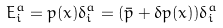<formula> <loc_0><loc_0><loc_500><loc_500>E ^ { a } _ { i } = p ( x ) \delta ^ { a } _ { i } = ( \bar { p } + \delta p ( x ) ) \delta _ { i } ^ { a }</formula> 